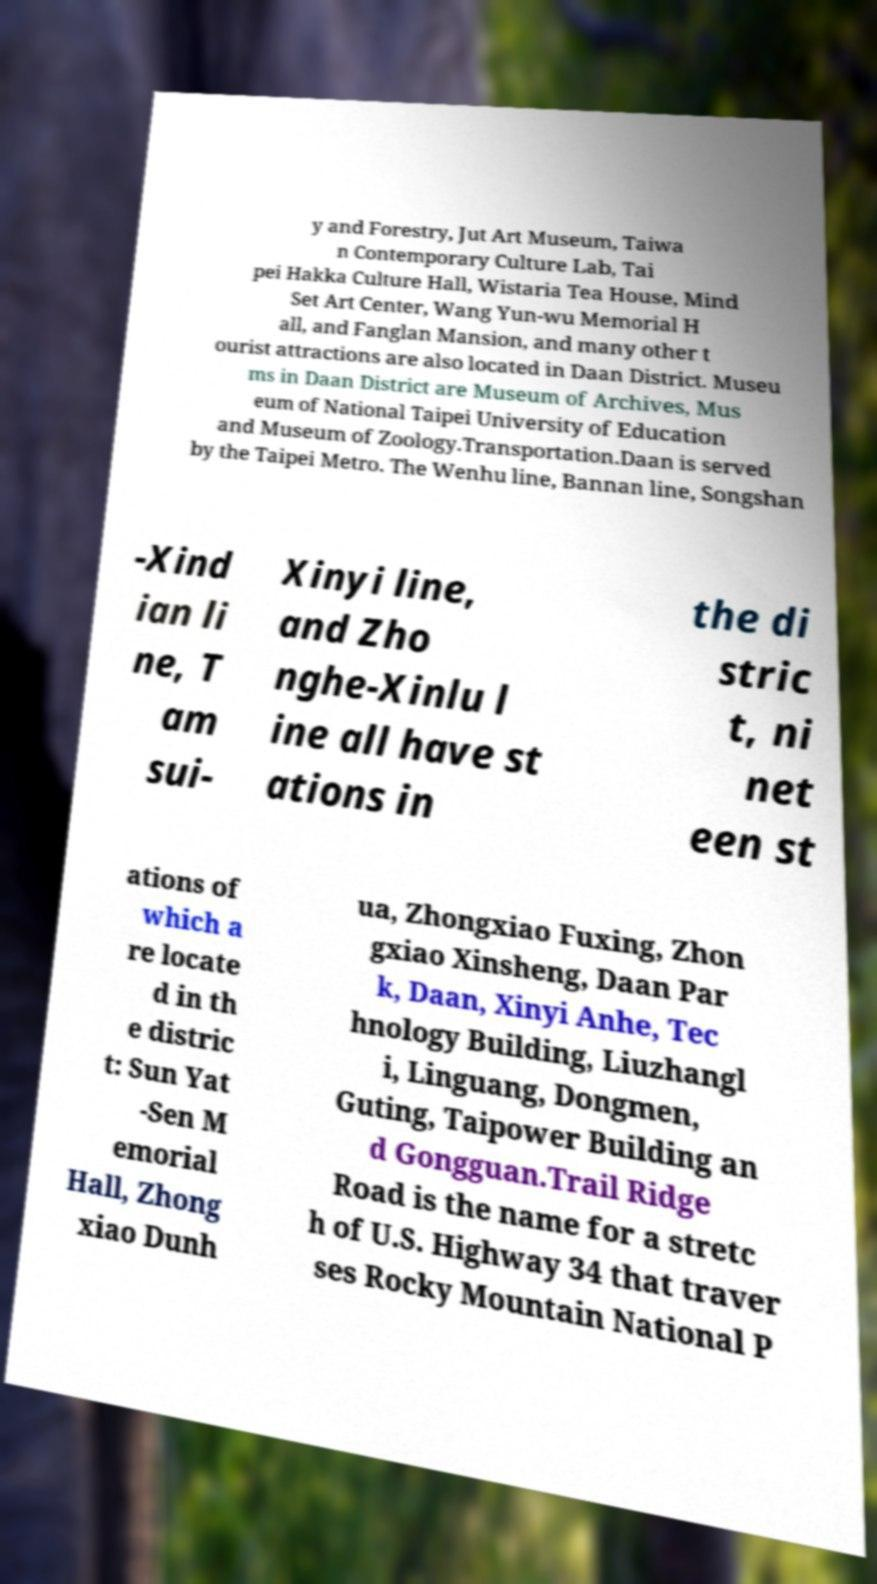Can you read and provide the text displayed in the image?This photo seems to have some interesting text. Can you extract and type it out for me? y and Forestry, Jut Art Museum, Taiwa n Contemporary Culture Lab, Tai pei Hakka Culture Hall, Wistaria Tea House, Mind Set Art Center, Wang Yun-wu Memorial H all, and Fanglan Mansion, and many other t ourist attractions are also located in Daan District. Museu ms in Daan District are Museum of Archives, Mus eum of National Taipei University of Education and Museum of Zoology.Transportation.Daan is served by the Taipei Metro. The Wenhu line, Bannan line, Songshan -Xind ian li ne, T am sui- Xinyi line, and Zho nghe-Xinlu l ine all have st ations in the di stric t, ni net een st ations of which a re locate d in th e distric t: Sun Yat -Sen M emorial Hall, Zhong xiao Dunh ua, Zhongxiao Fuxing, Zhon gxiao Xinsheng, Daan Par k, Daan, Xinyi Anhe, Tec hnology Building, Liuzhangl i, Linguang, Dongmen, Guting, Taipower Building an d Gongguan.Trail Ridge Road is the name for a stretc h of U.S. Highway 34 that traver ses Rocky Mountain National P 